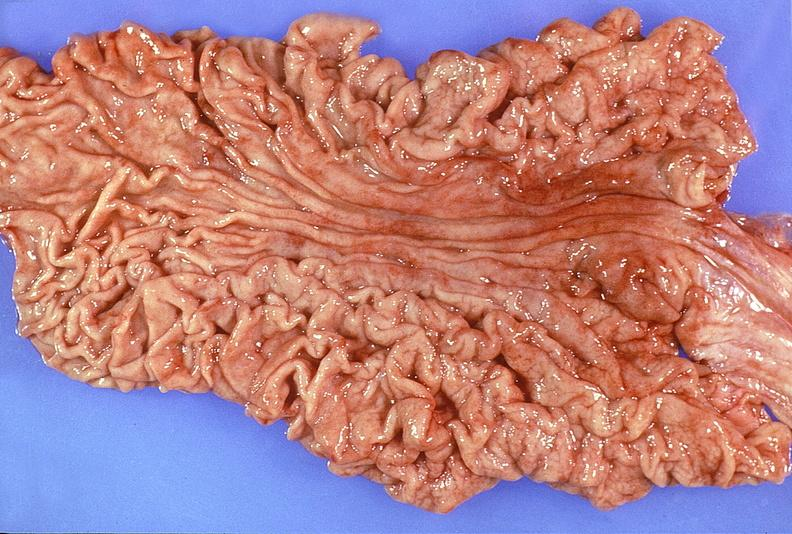does omphalocele show normal stomach?
Answer the question using a single word or phrase. No 